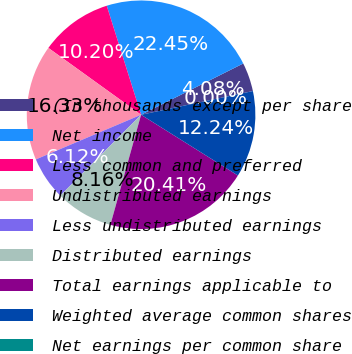Convert chart. <chart><loc_0><loc_0><loc_500><loc_500><pie_chart><fcel>(In thousands except per share<fcel>Net income<fcel>Less common and preferred<fcel>Undistributed earnings<fcel>Less undistributed earnings<fcel>Distributed earnings<fcel>Total earnings applicable to<fcel>Weighted average common shares<fcel>Net earnings per common share<nl><fcel>4.08%<fcel>22.45%<fcel>10.2%<fcel>16.33%<fcel>6.12%<fcel>8.16%<fcel>20.41%<fcel>12.24%<fcel>0.0%<nl></chart> 